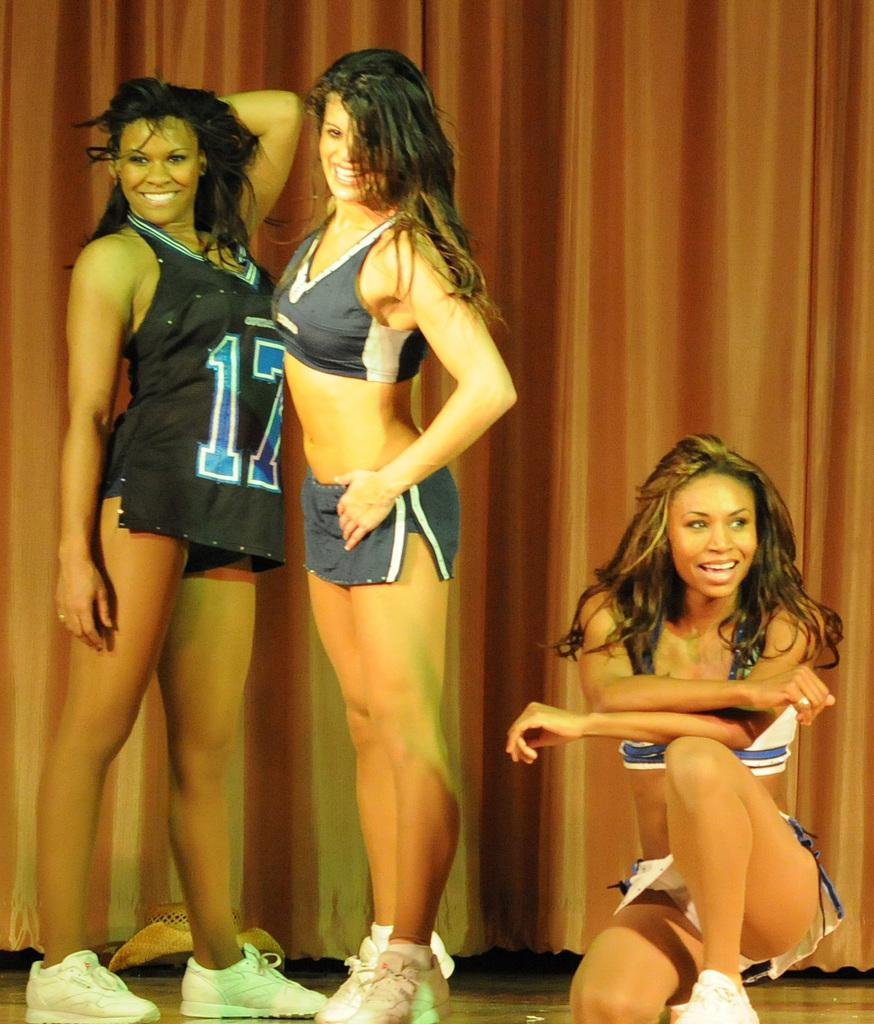<image>
Write a terse but informative summary of the picture. two women posing standing with one wearing a jersey number 17 and one 1/2 kneeling 